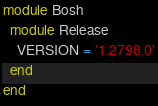Convert code to text. <code><loc_0><loc_0><loc_500><loc_500><_Ruby_>module Bosh
  module Release
    VERSION = '1.2798.0'
  end
end
</code> 